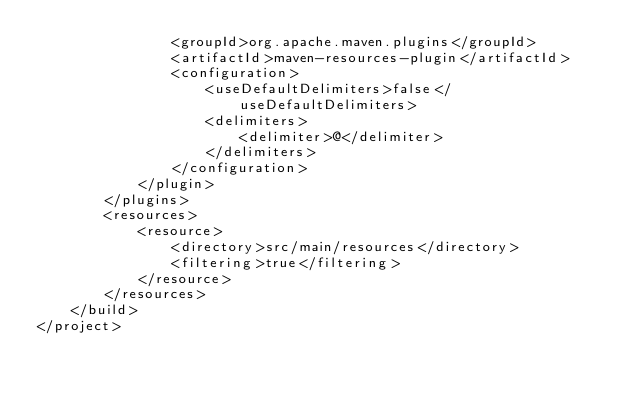<code> <loc_0><loc_0><loc_500><loc_500><_XML_>                <groupId>org.apache.maven.plugins</groupId>
                <artifactId>maven-resources-plugin</artifactId>
                <configuration>
                    <useDefaultDelimiters>false</useDefaultDelimiters>
                    <delimiters>
                        <delimiter>@</delimiter>
                    </delimiters>
                </configuration>
            </plugin>
        </plugins>
        <resources>
            <resource>
                <directory>src/main/resources</directory>
                <filtering>true</filtering>
            </resource>
        </resources>
    </build>
</project></code> 